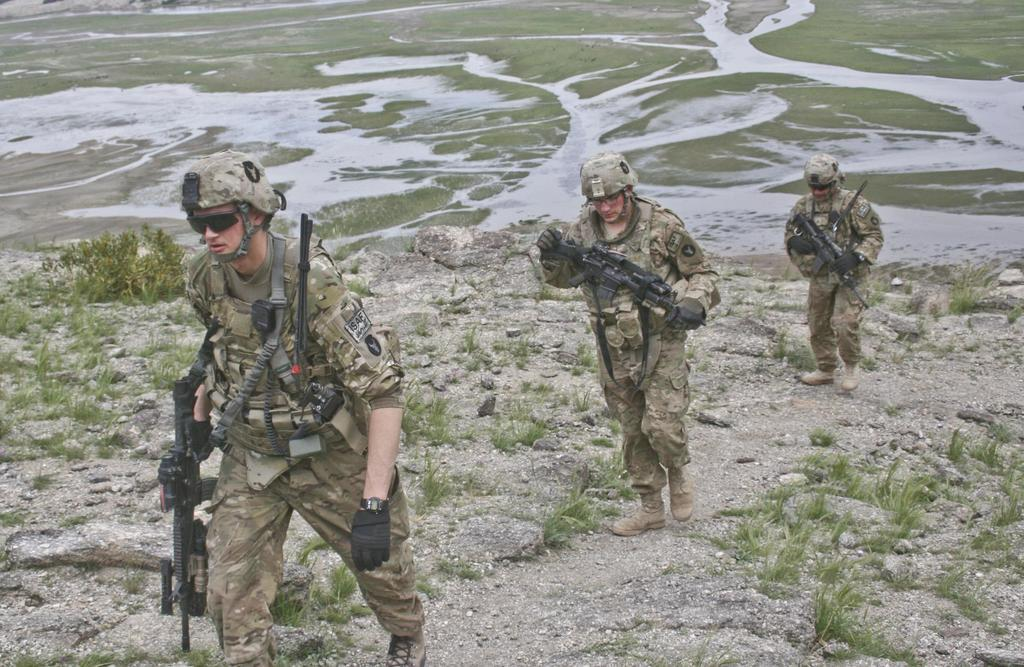How many army personnel are in the image? There are three army personnel in the image. What are the army personnel doing in the image? The army personnel are walking in the image. What are the army personnel holding in the image? The army personnel are holding guns in the image. What type of terrain is visible in the image? There are stones on the ground in the image, and the background includes ground. How many rays of sunlight can be seen in the image? There is no mention of sunlight or rays in the image; it only describes the presence of army personnel, their actions, and the terrain. 